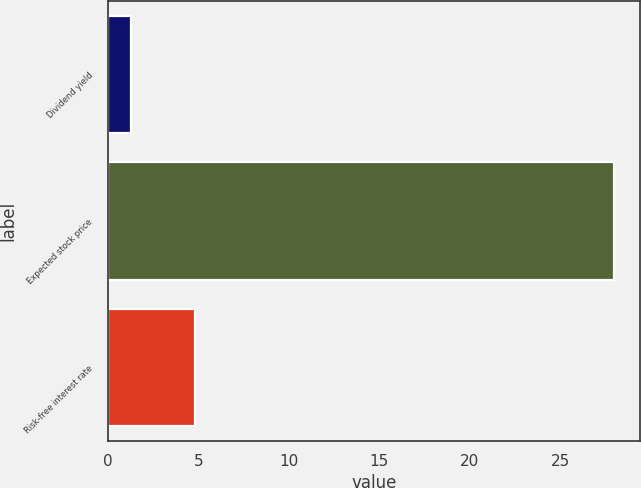<chart> <loc_0><loc_0><loc_500><loc_500><bar_chart><fcel>Dividend yield<fcel>Expected stock price<fcel>Risk-free interest rate<nl><fcel>1.3<fcel>28<fcel>4.8<nl></chart> 